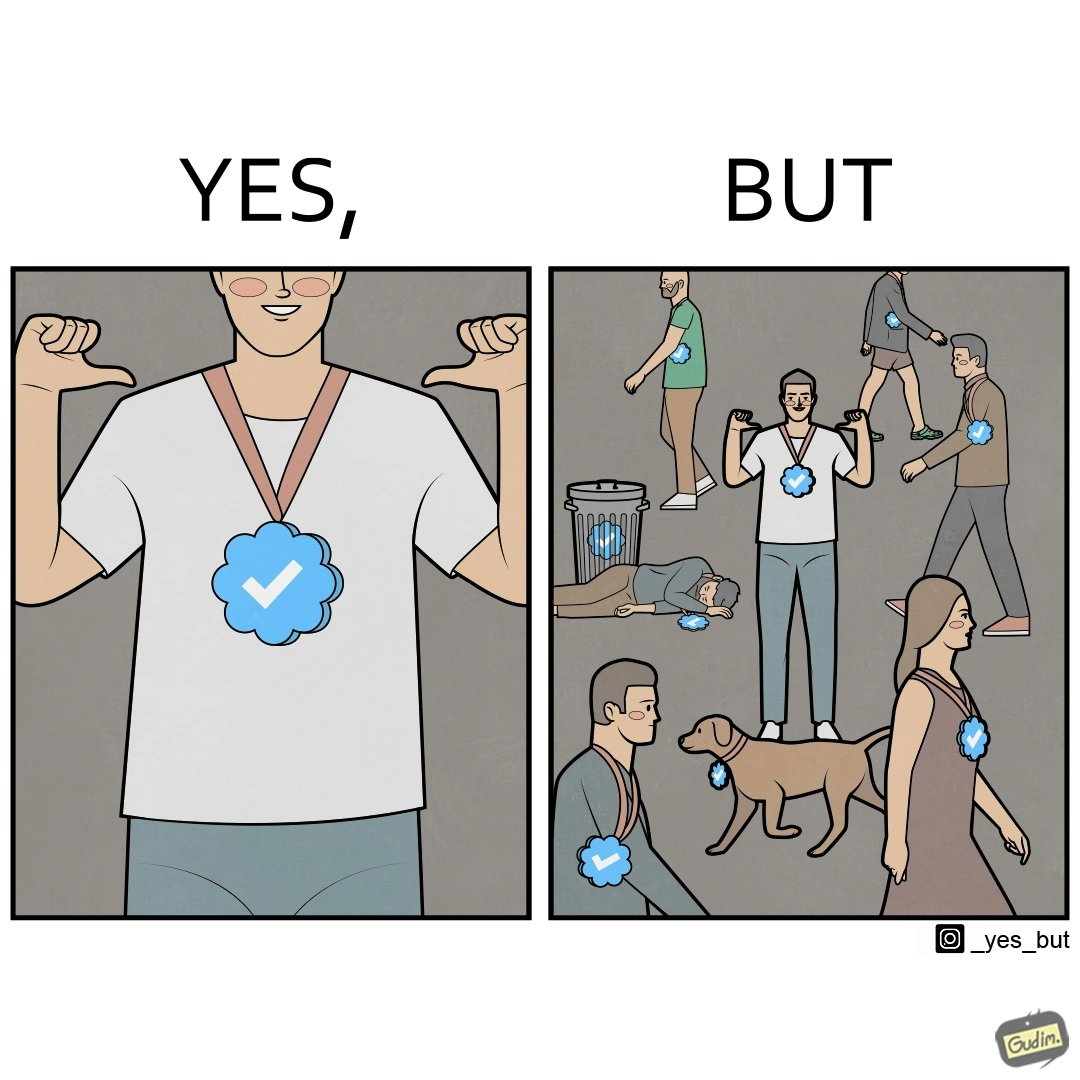Explain why this image is satirical. The images are funny since they show a man who thinks he has made a great achievement by winning a medal and is proud while everyone around him has the same medal and have achieved the same thing as he has 